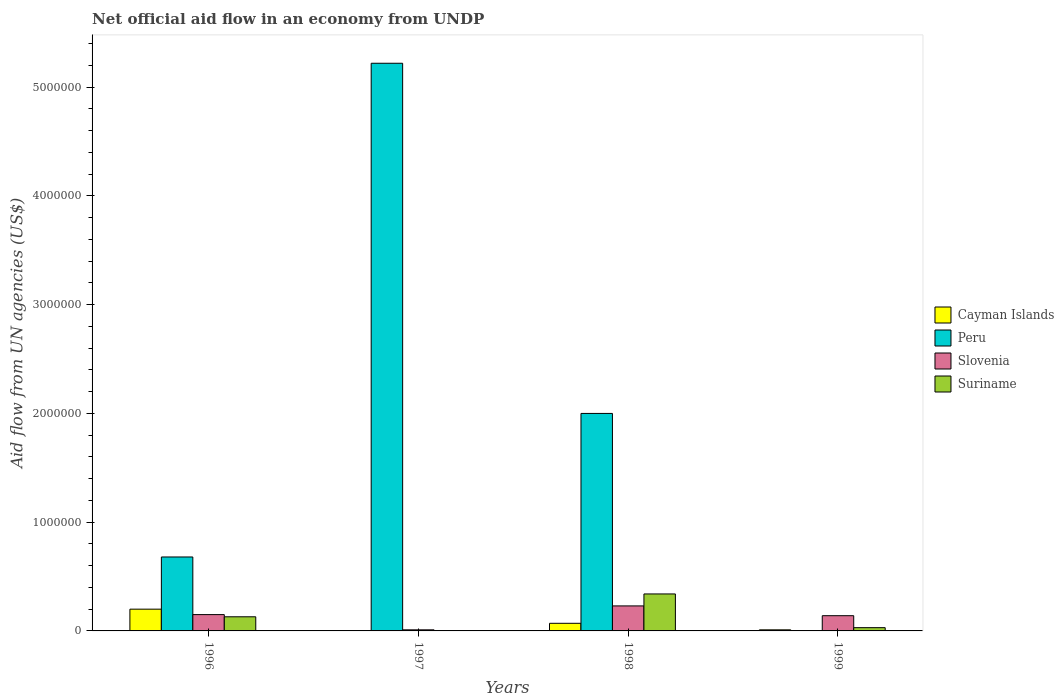How many different coloured bars are there?
Ensure brevity in your answer.  4. How many groups of bars are there?
Offer a very short reply. 4. Are the number of bars per tick equal to the number of legend labels?
Ensure brevity in your answer.  No. How many bars are there on the 1st tick from the right?
Offer a very short reply. 3. What is the net official aid flow in Peru in 1997?
Your response must be concise. 5.22e+06. Across all years, what is the minimum net official aid flow in Suriname?
Your answer should be very brief. 0. What is the total net official aid flow in Suriname in the graph?
Make the answer very short. 5.00e+05. What is the difference between the net official aid flow in Slovenia in 1997 and that in 1998?
Offer a very short reply. -2.20e+05. What is the difference between the net official aid flow in Cayman Islands in 1999 and the net official aid flow in Peru in 1996?
Make the answer very short. -6.70e+05. What is the average net official aid flow in Peru per year?
Offer a very short reply. 1.98e+06. In the year 1998, what is the difference between the net official aid flow in Peru and net official aid flow in Slovenia?
Your answer should be very brief. 1.77e+06. What is the ratio of the net official aid flow in Slovenia in 1996 to that in 1998?
Offer a very short reply. 0.65. Is the net official aid flow in Slovenia in 1996 less than that in 1997?
Your answer should be compact. No. Is the difference between the net official aid flow in Peru in 1997 and 1998 greater than the difference between the net official aid flow in Slovenia in 1997 and 1998?
Your answer should be very brief. Yes. What is the difference between the highest and the second highest net official aid flow in Slovenia?
Give a very brief answer. 8.00e+04. What is the difference between the highest and the lowest net official aid flow in Peru?
Offer a terse response. 5.22e+06. Is it the case that in every year, the sum of the net official aid flow in Slovenia and net official aid flow in Cayman Islands is greater than the net official aid flow in Peru?
Provide a succinct answer. No. How many bars are there?
Your response must be concise. 13. Are all the bars in the graph horizontal?
Make the answer very short. No. What is the difference between two consecutive major ticks on the Y-axis?
Keep it short and to the point. 1.00e+06. Does the graph contain grids?
Ensure brevity in your answer.  No. Where does the legend appear in the graph?
Your answer should be very brief. Center right. How are the legend labels stacked?
Offer a terse response. Vertical. What is the title of the graph?
Offer a very short reply. Net official aid flow in an economy from UNDP. Does "Qatar" appear as one of the legend labels in the graph?
Ensure brevity in your answer.  No. What is the label or title of the Y-axis?
Your answer should be very brief. Aid flow from UN agencies (US$). What is the Aid flow from UN agencies (US$) of Peru in 1996?
Your response must be concise. 6.80e+05. What is the Aid flow from UN agencies (US$) of Suriname in 1996?
Provide a succinct answer. 1.30e+05. What is the Aid flow from UN agencies (US$) in Peru in 1997?
Provide a succinct answer. 5.22e+06. What is the Aid flow from UN agencies (US$) of Suriname in 1997?
Offer a very short reply. 0. What is the Aid flow from UN agencies (US$) of Cayman Islands in 1998?
Give a very brief answer. 7.00e+04. What is the Aid flow from UN agencies (US$) of Peru in 1998?
Your answer should be very brief. 2.00e+06. What is the Aid flow from UN agencies (US$) of Slovenia in 1998?
Your answer should be compact. 2.30e+05. What is the Aid flow from UN agencies (US$) of Cayman Islands in 1999?
Provide a short and direct response. 10000. What is the Aid flow from UN agencies (US$) of Peru in 1999?
Keep it short and to the point. 0. What is the Aid flow from UN agencies (US$) of Slovenia in 1999?
Provide a succinct answer. 1.40e+05. What is the Aid flow from UN agencies (US$) in Suriname in 1999?
Offer a very short reply. 3.00e+04. Across all years, what is the maximum Aid flow from UN agencies (US$) of Peru?
Provide a succinct answer. 5.22e+06. Across all years, what is the maximum Aid flow from UN agencies (US$) of Slovenia?
Ensure brevity in your answer.  2.30e+05. Across all years, what is the minimum Aid flow from UN agencies (US$) in Peru?
Keep it short and to the point. 0. Across all years, what is the minimum Aid flow from UN agencies (US$) in Slovenia?
Your response must be concise. 10000. What is the total Aid flow from UN agencies (US$) of Peru in the graph?
Your answer should be compact. 7.90e+06. What is the total Aid flow from UN agencies (US$) of Slovenia in the graph?
Offer a terse response. 5.30e+05. What is the total Aid flow from UN agencies (US$) in Suriname in the graph?
Make the answer very short. 5.00e+05. What is the difference between the Aid flow from UN agencies (US$) in Peru in 1996 and that in 1997?
Keep it short and to the point. -4.54e+06. What is the difference between the Aid flow from UN agencies (US$) in Slovenia in 1996 and that in 1997?
Give a very brief answer. 1.40e+05. What is the difference between the Aid flow from UN agencies (US$) of Cayman Islands in 1996 and that in 1998?
Your response must be concise. 1.30e+05. What is the difference between the Aid flow from UN agencies (US$) of Peru in 1996 and that in 1998?
Ensure brevity in your answer.  -1.32e+06. What is the difference between the Aid flow from UN agencies (US$) in Slovenia in 1996 and that in 1998?
Make the answer very short. -8.00e+04. What is the difference between the Aid flow from UN agencies (US$) in Suriname in 1996 and that in 1998?
Keep it short and to the point. -2.10e+05. What is the difference between the Aid flow from UN agencies (US$) of Cayman Islands in 1996 and that in 1999?
Your answer should be compact. 1.90e+05. What is the difference between the Aid flow from UN agencies (US$) in Slovenia in 1996 and that in 1999?
Your answer should be compact. 10000. What is the difference between the Aid flow from UN agencies (US$) of Peru in 1997 and that in 1998?
Ensure brevity in your answer.  3.22e+06. What is the difference between the Aid flow from UN agencies (US$) in Slovenia in 1997 and that in 1999?
Keep it short and to the point. -1.30e+05. What is the difference between the Aid flow from UN agencies (US$) of Cayman Islands in 1996 and the Aid flow from UN agencies (US$) of Peru in 1997?
Provide a short and direct response. -5.02e+06. What is the difference between the Aid flow from UN agencies (US$) in Cayman Islands in 1996 and the Aid flow from UN agencies (US$) in Slovenia in 1997?
Your response must be concise. 1.90e+05. What is the difference between the Aid flow from UN agencies (US$) of Peru in 1996 and the Aid flow from UN agencies (US$) of Slovenia in 1997?
Make the answer very short. 6.70e+05. What is the difference between the Aid flow from UN agencies (US$) of Cayman Islands in 1996 and the Aid flow from UN agencies (US$) of Peru in 1998?
Offer a very short reply. -1.80e+06. What is the difference between the Aid flow from UN agencies (US$) of Cayman Islands in 1996 and the Aid flow from UN agencies (US$) of Slovenia in 1998?
Make the answer very short. -3.00e+04. What is the difference between the Aid flow from UN agencies (US$) in Cayman Islands in 1996 and the Aid flow from UN agencies (US$) in Suriname in 1998?
Give a very brief answer. -1.40e+05. What is the difference between the Aid flow from UN agencies (US$) of Peru in 1996 and the Aid flow from UN agencies (US$) of Slovenia in 1998?
Provide a short and direct response. 4.50e+05. What is the difference between the Aid flow from UN agencies (US$) in Peru in 1996 and the Aid flow from UN agencies (US$) in Suriname in 1998?
Your response must be concise. 3.40e+05. What is the difference between the Aid flow from UN agencies (US$) of Slovenia in 1996 and the Aid flow from UN agencies (US$) of Suriname in 1998?
Your answer should be very brief. -1.90e+05. What is the difference between the Aid flow from UN agencies (US$) of Cayman Islands in 1996 and the Aid flow from UN agencies (US$) of Slovenia in 1999?
Offer a terse response. 6.00e+04. What is the difference between the Aid flow from UN agencies (US$) of Peru in 1996 and the Aid flow from UN agencies (US$) of Slovenia in 1999?
Offer a very short reply. 5.40e+05. What is the difference between the Aid flow from UN agencies (US$) of Peru in 1996 and the Aid flow from UN agencies (US$) of Suriname in 1999?
Keep it short and to the point. 6.50e+05. What is the difference between the Aid flow from UN agencies (US$) of Slovenia in 1996 and the Aid flow from UN agencies (US$) of Suriname in 1999?
Provide a succinct answer. 1.20e+05. What is the difference between the Aid flow from UN agencies (US$) of Peru in 1997 and the Aid flow from UN agencies (US$) of Slovenia in 1998?
Your answer should be very brief. 4.99e+06. What is the difference between the Aid flow from UN agencies (US$) in Peru in 1997 and the Aid flow from UN agencies (US$) in Suriname in 1998?
Provide a succinct answer. 4.88e+06. What is the difference between the Aid flow from UN agencies (US$) of Slovenia in 1997 and the Aid flow from UN agencies (US$) of Suriname in 1998?
Provide a short and direct response. -3.30e+05. What is the difference between the Aid flow from UN agencies (US$) of Peru in 1997 and the Aid flow from UN agencies (US$) of Slovenia in 1999?
Provide a short and direct response. 5.08e+06. What is the difference between the Aid flow from UN agencies (US$) of Peru in 1997 and the Aid flow from UN agencies (US$) of Suriname in 1999?
Ensure brevity in your answer.  5.19e+06. What is the difference between the Aid flow from UN agencies (US$) in Slovenia in 1997 and the Aid flow from UN agencies (US$) in Suriname in 1999?
Your response must be concise. -2.00e+04. What is the difference between the Aid flow from UN agencies (US$) in Cayman Islands in 1998 and the Aid flow from UN agencies (US$) in Slovenia in 1999?
Your answer should be compact. -7.00e+04. What is the difference between the Aid flow from UN agencies (US$) in Peru in 1998 and the Aid flow from UN agencies (US$) in Slovenia in 1999?
Provide a short and direct response. 1.86e+06. What is the difference between the Aid flow from UN agencies (US$) of Peru in 1998 and the Aid flow from UN agencies (US$) of Suriname in 1999?
Make the answer very short. 1.97e+06. What is the difference between the Aid flow from UN agencies (US$) of Slovenia in 1998 and the Aid flow from UN agencies (US$) of Suriname in 1999?
Your response must be concise. 2.00e+05. What is the average Aid flow from UN agencies (US$) of Cayman Islands per year?
Your answer should be compact. 7.00e+04. What is the average Aid flow from UN agencies (US$) of Peru per year?
Provide a short and direct response. 1.98e+06. What is the average Aid flow from UN agencies (US$) of Slovenia per year?
Your response must be concise. 1.32e+05. What is the average Aid flow from UN agencies (US$) in Suriname per year?
Give a very brief answer. 1.25e+05. In the year 1996, what is the difference between the Aid flow from UN agencies (US$) in Cayman Islands and Aid flow from UN agencies (US$) in Peru?
Offer a very short reply. -4.80e+05. In the year 1996, what is the difference between the Aid flow from UN agencies (US$) of Peru and Aid flow from UN agencies (US$) of Slovenia?
Ensure brevity in your answer.  5.30e+05. In the year 1997, what is the difference between the Aid flow from UN agencies (US$) of Peru and Aid flow from UN agencies (US$) of Slovenia?
Provide a succinct answer. 5.21e+06. In the year 1998, what is the difference between the Aid flow from UN agencies (US$) in Cayman Islands and Aid flow from UN agencies (US$) in Peru?
Your answer should be very brief. -1.93e+06. In the year 1998, what is the difference between the Aid flow from UN agencies (US$) in Cayman Islands and Aid flow from UN agencies (US$) in Suriname?
Offer a terse response. -2.70e+05. In the year 1998, what is the difference between the Aid flow from UN agencies (US$) of Peru and Aid flow from UN agencies (US$) of Slovenia?
Your response must be concise. 1.77e+06. In the year 1998, what is the difference between the Aid flow from UN agencies (US$) of Peru and Aid flow from UN agencies (US$) of Suriname?
Your answer should be very brief. 1.66e+06. In the year 1998, what is the difference between the Aid flow from UN agencies (US$) in Slovenia and Aid flow from UN agencies (US$) in Suriname?
Your response must be concise. -1.10e+05. What is the ratio of the Aid flow from UN agencies (US$) in Peru in 1996 to that in 1997?
Your response must be concise. 0.13. What is the ratio of the Aid flow from UN agencies (US$) in Slovenia in 1996 to that in 1997?
Provide a succinct answer. 15. What is the ratio of the Aid flow from UN agencies (US$) in Cayman Islands in 1996 to that in 1998?
Give a very brief answer. 2.86. What is the ratio of the Aid flow from UN agencies (US$) in Peru in 1996 to that in 1998?
Provide a succinct answer. 0.34. What is the ratio of the Aid flow from UN agencies (US$) of Slovenia in 1996 to that in 1998?
Your answer should be compact. 0.65. What is the ratio of the Aid flow from UN agencies (US$) of Suriname in 1996 to that in 1998?
Provide a succinct answer. 0.38. What is the ratio of the Aid flow from UN agencies (US$) of Slovenia in 1996 to that in 1999?
Give a very brief answer. 1.07. What is the ratio of the Aid flow from UN agencies (US$) of Suriname in 1996 to that in 1999?
Provide a succinct answer. 4.33. What is the ratio of the Aid flow from UN agencies (US$) in Peru in 1997 to that in 1998?
Your response must be concise. 2.61. What is the ratio of the Aid flow from UN agencies (US$) in Slovenia in 1997 to that in 1998?
Your response must be concise. 0.04. What is the ratio of the Aid flow from UN agencies (US$) in Slovenia in 1997 to that in 1999?
Provide a succinct answer. 0.07. What is the ratio of the Aid flow from UN agencies (US$) of Cayman Islands in 1998 to that in 1999?
Your answer should be compact. 7. What is the ratio of the Aid flow from UN agencies (US$) in Slovenia in 1998 to that in 1999?
Give a very brief answer. 1.64. What is the ratio of the Aid flow from UN agencies (US$) in Suriname in 1998 to that in 1999?
Your answer should be compact. 11.33. What is the difference between the highest and the second highest Aid flow from UN agencies (US$) in Cayman Islands?
Provide a short and direct response. 1.30e+05. What is the difference between the highest and the second highest Aid flow from UN agencies (US$) in Peru?
Your answer should be compact. 3.22e+06. What is the difference between the highest and the second highest Aid flow from UN agencies (US$) of Suriname?
Your answer should be very brief. 2.10e+05. What is the difference between the highest and the lowest Aid flow from UN agencies (US$) of Peru?
Make the answer very short. 5.22e+06. What is the difference between the highest and the lowest Aid flow from UN agencies (US$) in Slovenia?
Provide a succinct answer. 2.20e+05. 